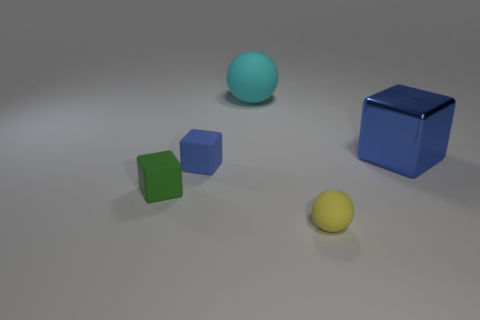What is the color of the large object to the left of the large cube?
Keep it short and to the point. Cyan. Is the number of tiny rubber objects that are behind the yellow matte ball greater than the number of tiny blue blocks?
Make the answer very short. Yes. How many other objects are the same size as the yellow object?
Keep it short and to the point. 2. There is a large rubber sphere; how many blue shiny objects are to the left of it?
Keep it short and to the point. 0. Are there an equal number of yellow matte spheres right of the large sphere and cubes that are in front of the metal object?
Your answer should be compact. No. The blue metal object that is the same shape as the tiny green thing is what size?
Provide a succinct answer. Large. The thing behind the large blue object has what shape?
Your answer should be very brief. Sphere. Does the blue cube that is to the right of the tiny yellow thing have the same material as the small object in front of the small green block?
Offer a terse response. No. The green thing is what shape?
Ensure brevity in your answer.  Cube. Are there the same number of rubber blocks that are behind the small blue block and yellow things?
Keep it short and to the point. No. 